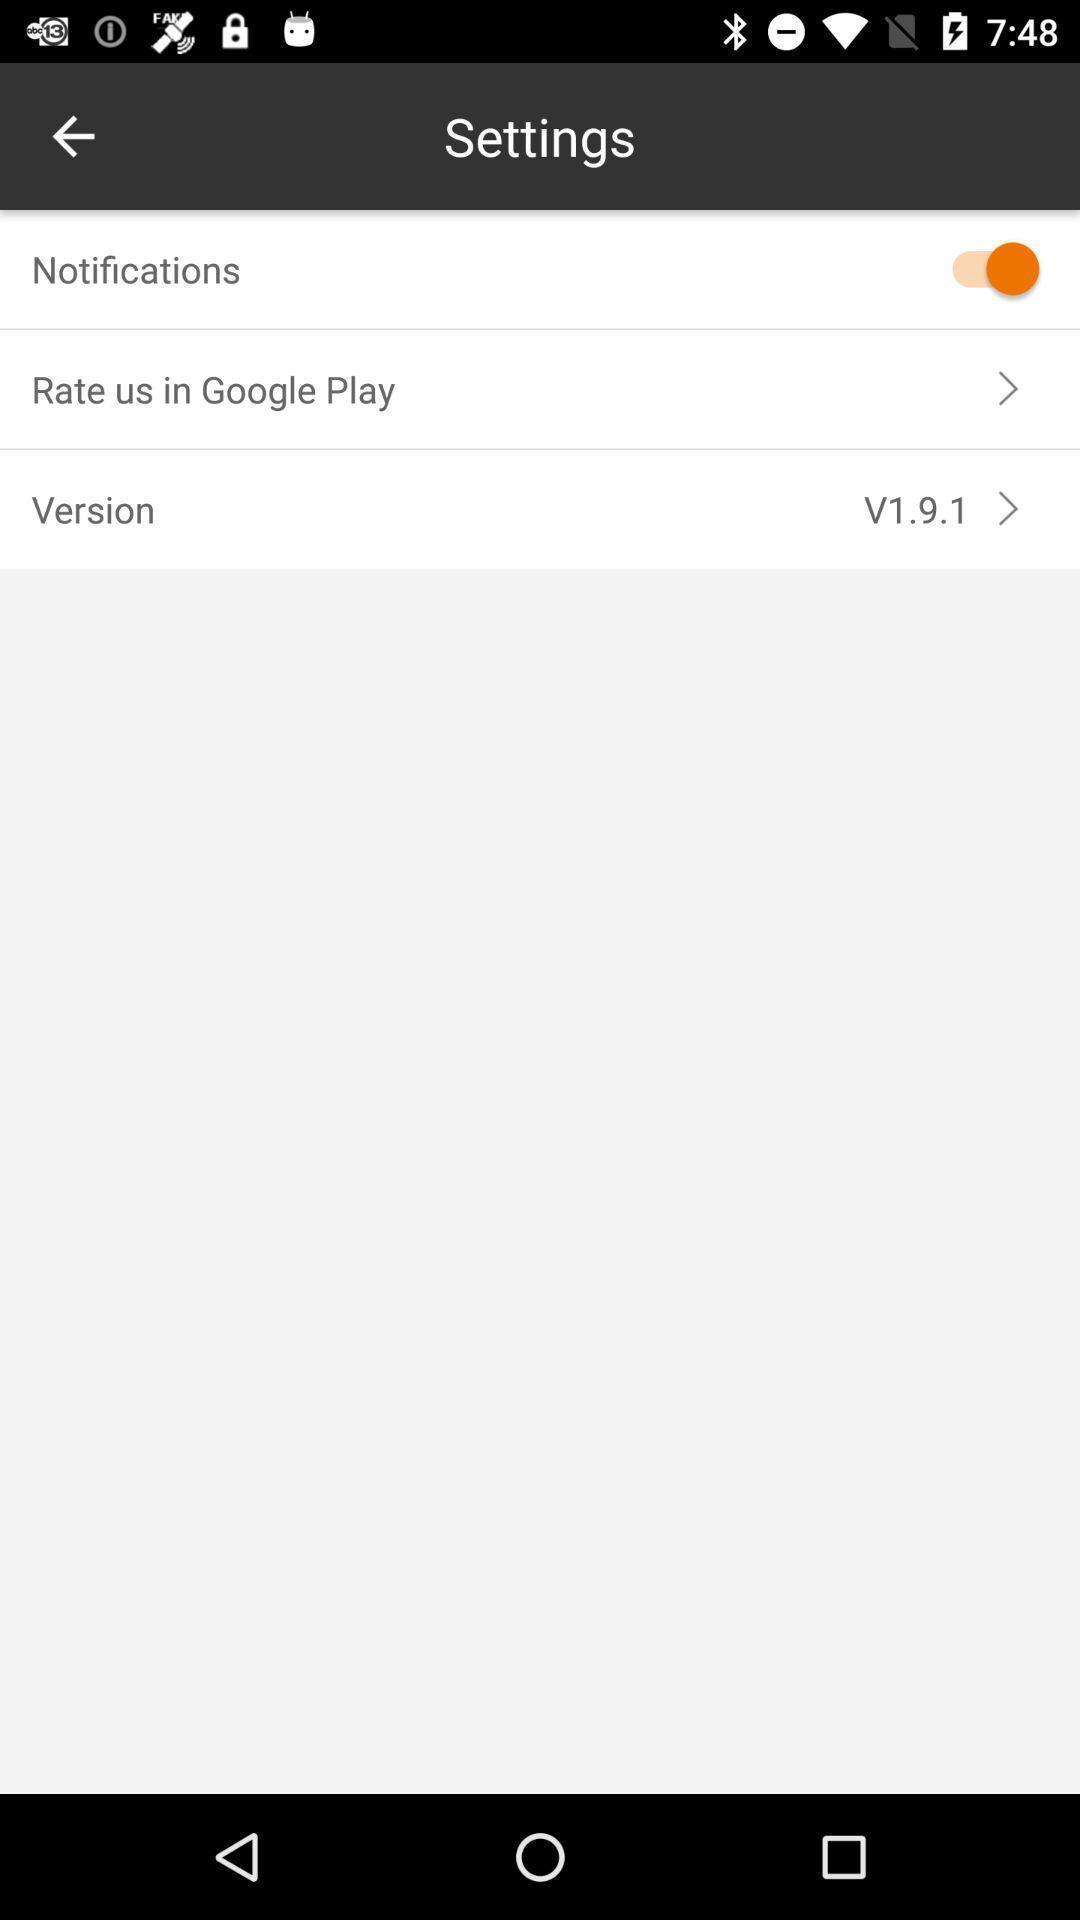What details can you identify in this image? Screen displaying settings page. 